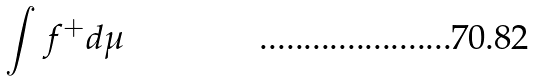<formula> <loc_0><loc_0><loc_500><loc_500>\int f ^ { + } d \mu</formula> 